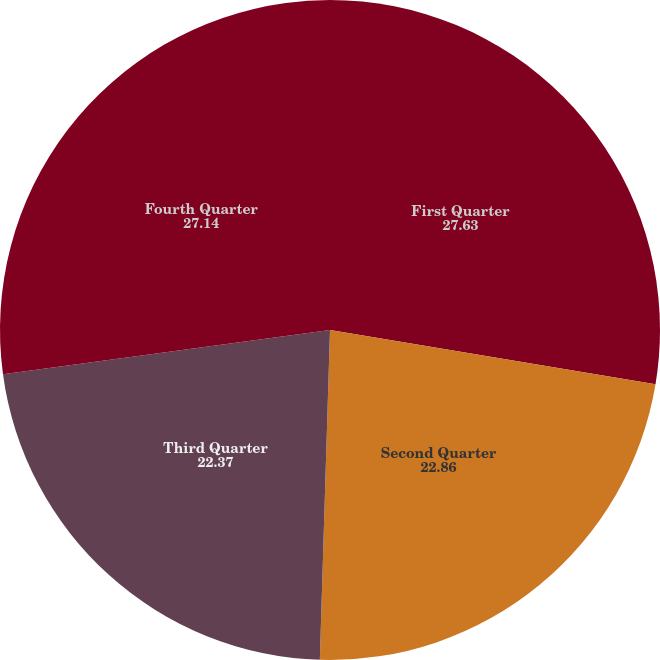Convert chart. <chart><loc_0><loc_0><loc_500><loc_500><pie_chart><fcel>First Quarter<fcel>Second Quarter<fcel>Third Quarter<fcel>Fourth Quarter<nl><fcel>27.63%<fcel>22.86%<fcel>22.37%<fcel>27.14%<nl></chart> 